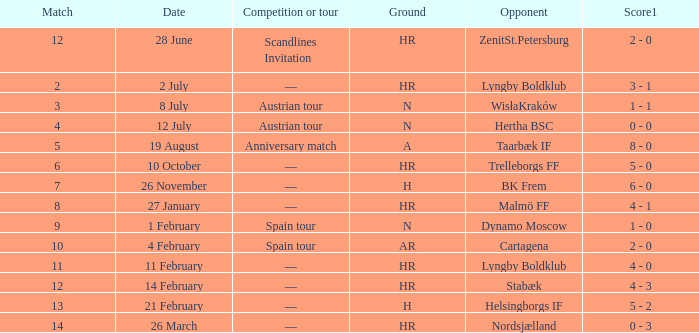In which match or circuit was nordsjælland the competitor with an hr ground? —. 